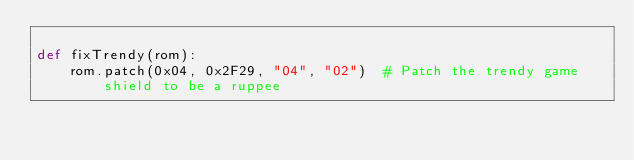<code> <loc_0><loc_0><loc_500><loc_500><_Python_>
def fixTrendy(rom):
    rom.patch(0x04, 0x2F29, "04", "02")  # Patch the trendy game shield to be a ruppee
</code> 